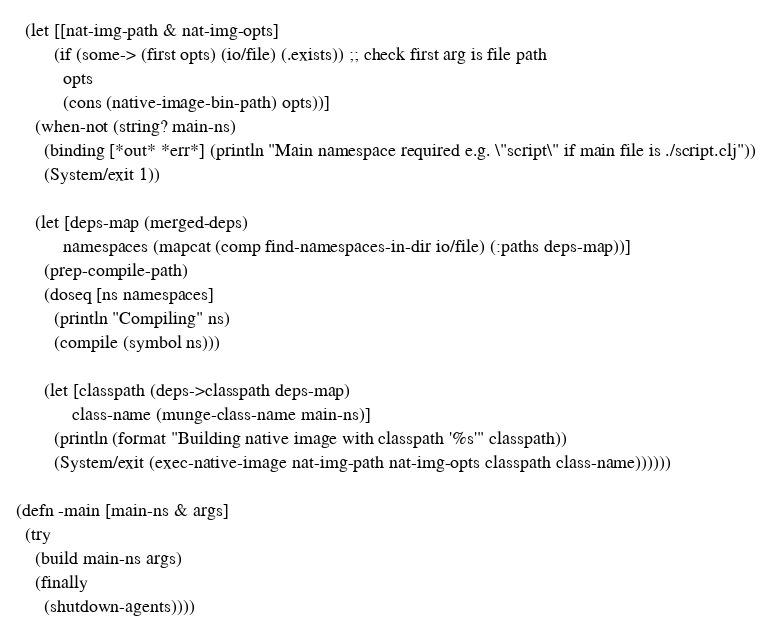Convert code to text. <code><loc_0><loc_0><loc_500><loc_500><_Clojure_>  (let [[nat-img-path & nat-img-opts]
        (if (some-> (first opts) (io/file) (.exists)) ;; check first arg is file path
          opts
          (cons (native-image-bin-path) opts))]
    (when-not (string? main-ns)
      (binding [*out* *err*] (println "Main namespace required e.g. \"script\" if main file is ./script.clj"))
      (System/exit 1))

    (let [deps-map (merged-deps)
          namespaces (mapcat (comp find-namespaces-in-dir io/file) (:paths deps-map))]
      (prep-compile-path)
      (doseq [ns namespaces]
        (println "Compiling" ns)
        (compile (symbol ns)))

      (let [classpath (deps->classpath deps-map)
            class-name (munge-class-name main-ns)]
        (println (format "Building native image with classpath '%s'" classpath))
        (System/exit (exec-native-image nat-img-path nat-img-opts classpath class-name))))))

(defn -main [main-ns & args]
  (try
    (build main-ns args)
    (finally
      (shutdown-agents))))
</code> 